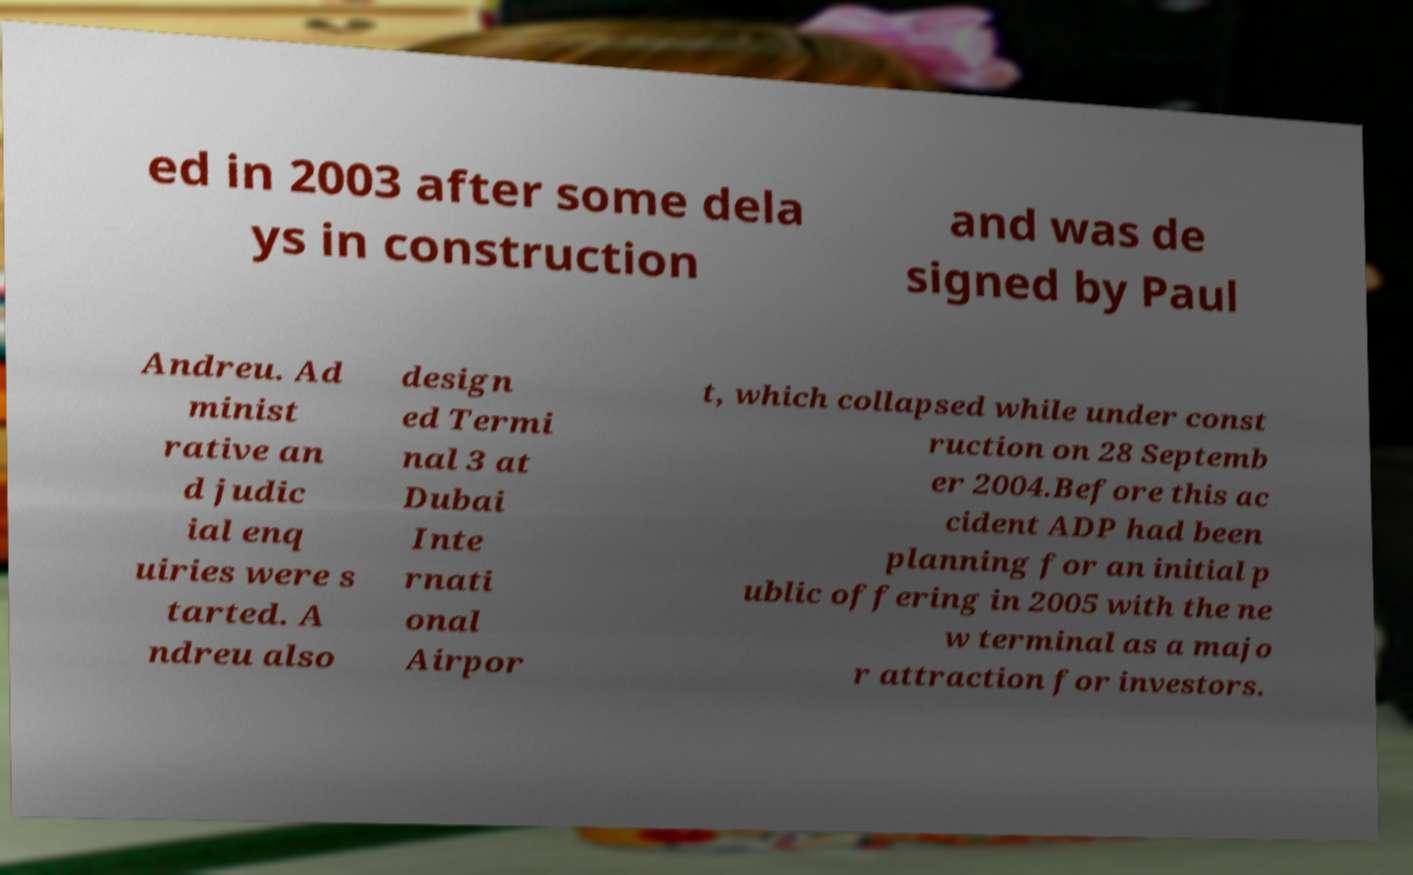Can you read and provide the text displayed in the image?This photo seems to have some interesting text. Can you extract and type it out for me? ed in 2003 after some dela ys in construction and was de signed by Paul Andreu. Ad minist rative an d judic ial enq uiries were s tarted. A ndreu also design ed Termi nal 3 at Dubai Inte rnati onal Airpor t, which collapsed while under const ruction on 28 Septemb er 2004.Before this ac cident ADP had been planning for an initial p ublic offering in 2005 with the ne w terminal as a majo r attraction for investors. 